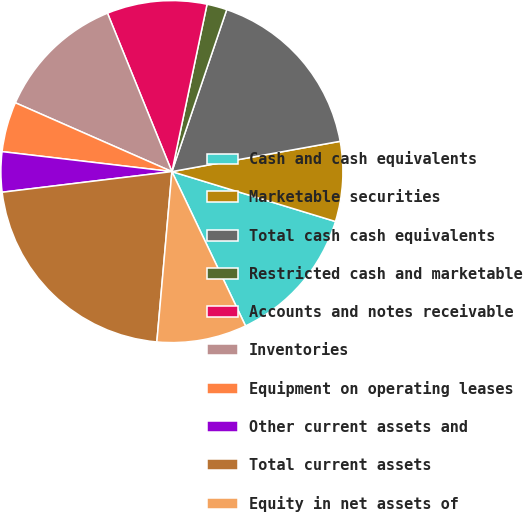Convert chart to OTSL. <chart><loc_0><loc_0><loc_500><loc_500><pie_chart><fcel>Cash and cash equivalents<fcel>Marketable securities<fcel>Total cash cash equivalents<fcel>Restricted cash and marketable<fcel>Accounts and notes receivable<fcel>Inventories<fcel>Equipment on operating leases<fcel>Other current assets and<fcel>Total current assets<fcel>Equity in net assets of<nl><fcel>13.2%<fcel>7.55%<fcel>16.97%<fcel>1.9%<fcel>9.44%<fcel>12.26%<fcel>4.73%<fcel>3.79%<fcel>21.67%<fcel>8.49%<nl></chart> 